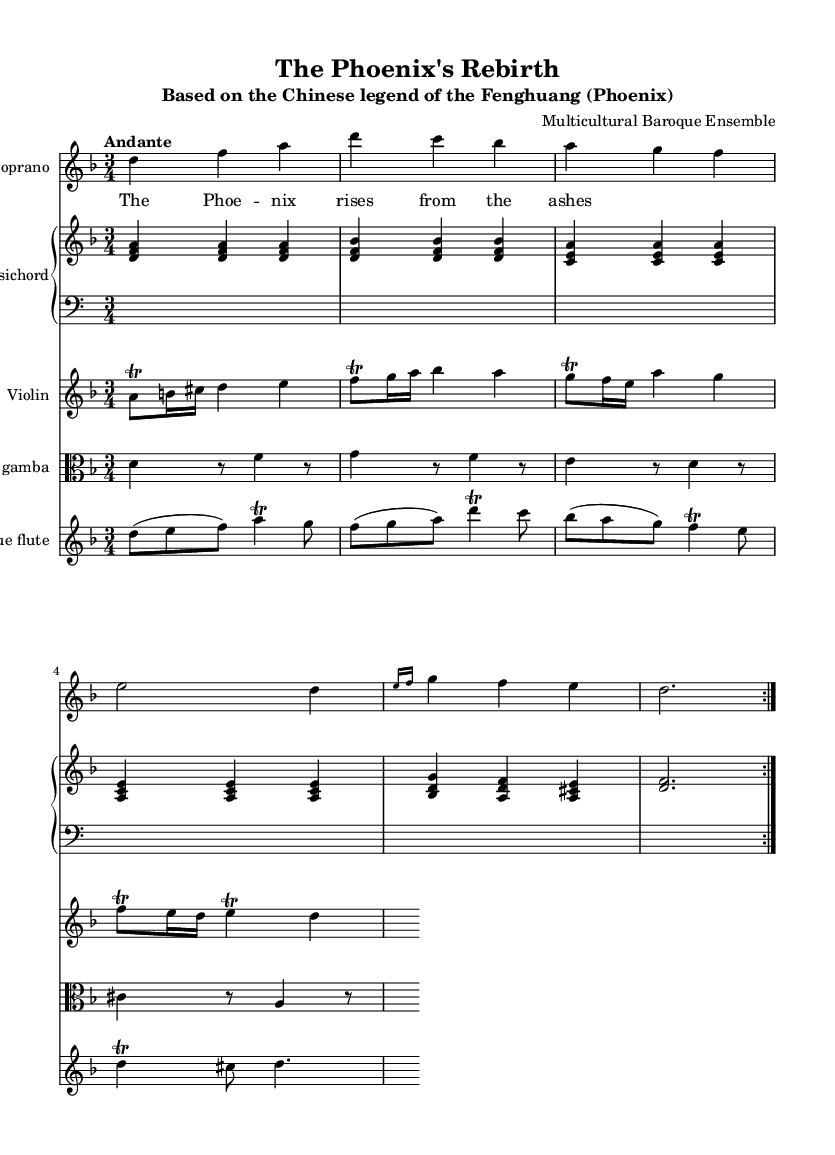What is the key signature of this music? The key signature is D minor, which has one flat (B flat). This can be identified by looking at the key signature marking at the beginning of the score.
Answer: D minor What is the time signature of the piece? The time signature is 3/4, which means there are three beats in each measure and a quarter note receives one beat. This is indicated at the beginning of the score next to the key signature.
Answer: 3/4 What tempo marking is given for the piece? The tempo marking is "Andante", indicating a moderate walking pace. This is located above the staff, indicating the desired speed of the performance.
Answer: Andante How many instruments are featured in this piece? There are five instruments in this piece: soprano, harpsichord, violin, viola da gamba, and baroque flute. This can be determined by counting the different staves in the score, each representing a different instrument or voice.
Answer: Five What folktale is the music based on? The music is based on the Chinese legend of the Fenghuang (Phoenix). This information is found in the subtitle of the score, directly under the title, which indicates the cultural reference for the piece.
Answer: Fenghuang (Phoenix) How is the thematic material introduced in the soprano part? The thematic material is introduced in the soprano part through the lyrics "The Phoenix rises from the ashes" set to the notes. This can be seen in the soprano staff where the melody is combined with the text, expressing the narrative of rebirth.
Answer: The Phoenix rises from the ashes What does the use of trills in the violin part indicate? The use of trills in the violin part indicates ornamentation, which is common in Baroque music, adding decorative flair to the melody. The written symbols show where the performer should execute a rapid alternation between notes, enhancing expressiveness.
Answer: Ornamentation 